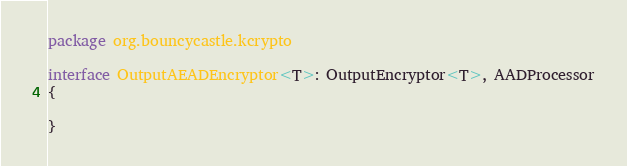<code> <loc_0><loc_0><loc_500><loc_500><_Kotlin_>package org.bouncycastle.kcrypto

interface OutputAEADEncryptor<T>: OutputEncryptor<T>, AADProcessor
{

}</code> 